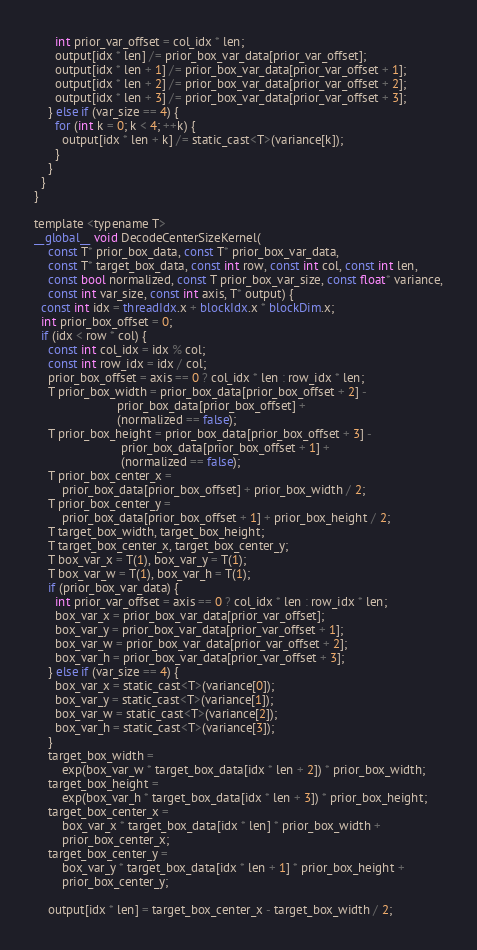<code> <loc_0><loc_0><loc_500><loc_500><_Cuda_>      int prior_var_offset = col_idx * len;
      output[idx * len] /= prior_box_var_data[prior_var_offset];
      output[idx * len + 1] /= prior_box_var_data[prior_var_offset + 1];
      output[idx * len + 2] /= prior_box_var_data[prior_var_offset + 2];
      output[idx * len + 3] /= prior_box_var_data[prior_var_offset + 3];
    } else if (var_size == 4) {
      for (int k = 0; k < 4; ++k) {
        output[idx * len + k] /= static_cast<T>(variance[k]);
      }
    }
  }
}

template <typename T>
__global__ void DecodeCenterSizeKernel(
    const T* prior_box_data, const T* prior_box_var_data,
    const T* target_box_data, const int row, const int col, const int len,
    const bool normalized, const T prior_box_var_size, const float* variance,
    const int var_size, const int axis, T* output) {
  const int idx = threadIdx.x + blockIdx.x * blockDim.x;
  int prior_box_offset = 0;
  if (idx < row * col) {
    const int col_idx = idx % col;
    const int row_idx = idx / col;
    prior_box_offset = axis == 0 ? col_idx * len : row_idx * len;
    T prior_box_width = prior_box_data[prior_box_offset + 2] -
                        prior_box_data[prior_box_offset] +
                        (normalized == false);
    T prior_box_height = prior_box_data[prior_box_offset + 3] -
                         prior_box_data[prior_box_offset + 1] +
                         (normalized == false);
    T prior_box_center_x =
        prior_box_data[prior_box_offset] + prior_box_width / 2;
    T prior_box_center_y =
        prior_box_data[prior_box_offset + 1] + prior_box_height / 2;
    T target_box_width, target_box_height;
    T target_box_center_x, target_box_center_y;
    T box_var_x = T(1), box_var_y = T(1);
    T box_var_w = T(1), box_var_h = T(1);
    if (prior_box_var_data) {
      int prior_var_offset = axis == 0 ? col_idx * len : row_idx * len;
      box_var_x = prior_box_var_data[prior_var_offset];
      box_var_y = prior_box_var_data[prior_var_offset + 1];
      box_var_w = prior_box_var_data[prior_var_offset + 2];
      box_var_h = prior_box_var_data[prior_var_offset + 3];
    } else if (var_size == 4) {
      box_var_x = static_cast<T>(variance[0]);
      box_var_y = static_cast<T>(variance[1]);
      box_var_w = static_cast<T>(variance[2]);
      box_var_h = static_cast<T>(variance[3]);
    }
    target_box_width =
        exp(box_var_w * target_box_data[idx * len + 2]) * prior_box_width;
    target_box_height =
        exp(box_var_h * target_box_data[idx * len + 3]) * prior_box_height;
    target_box_center_x =
        box_var_x * target_box_data[idx * len] * prior_box_width +
        prior_box_center_x;
    target_box_center_y =
        box_var_y * target_box_data[idx * len + 1] * prior_box_height +
        prior_box_center_y;

    output[idx * len] = target_box_center_x - target_box_width / 2;</code> 